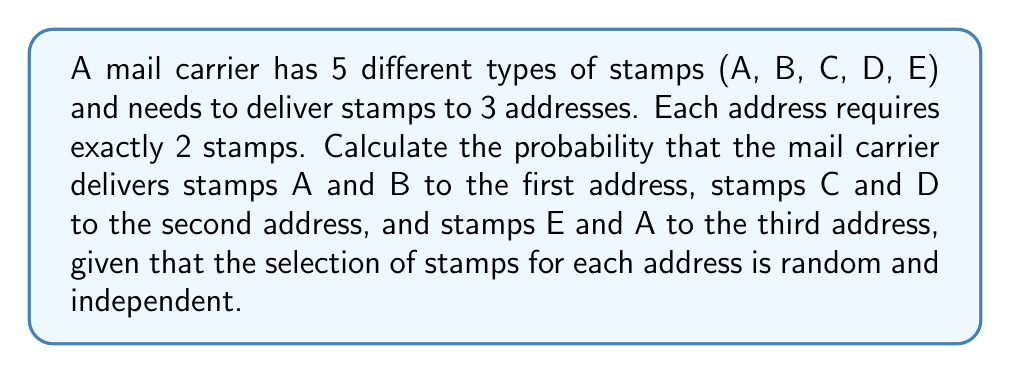Could you help me with this problem? Let's approach this step-by-step:

1) For each address, we need to calculate the probability of selecting the specific combination of stamps:

   First address (A and B): 
   $$P(\text{A and B}) = \frac{2}{5} \cdot \frac{1}{4} = \frac{1}{10}$$

   Second address (C and D):
   $$P(\text{C and D}) = \frac{2}{5} \cdot \frac{1}{4} = \frac{1}{10}$$

   Third address (E and A):
   $$P(\text{E and A}) = \frac{2}{5} \cdot \frac{1}{4} = \frac{1}{10}$$

2) Since the selections for each address are independent, we multiply these probabilities:

   $$P(\text{all correct}) = P(\text{A and B}) \cdot P(\text{C and D}) \cdot P(\text{E and A})$$

3) Substituting the values:

   $$P(\text{all correct}) = \frac{1}{10} \cdot \frac{1}{10} \cdot \frac{1}{10} = \frac{1}{1000}$$

Therefore, the probability of this specific combination occurring is $\frac{1}{1000}$ or $0.001$.
Answer: $\frac{1}{1000}$ 